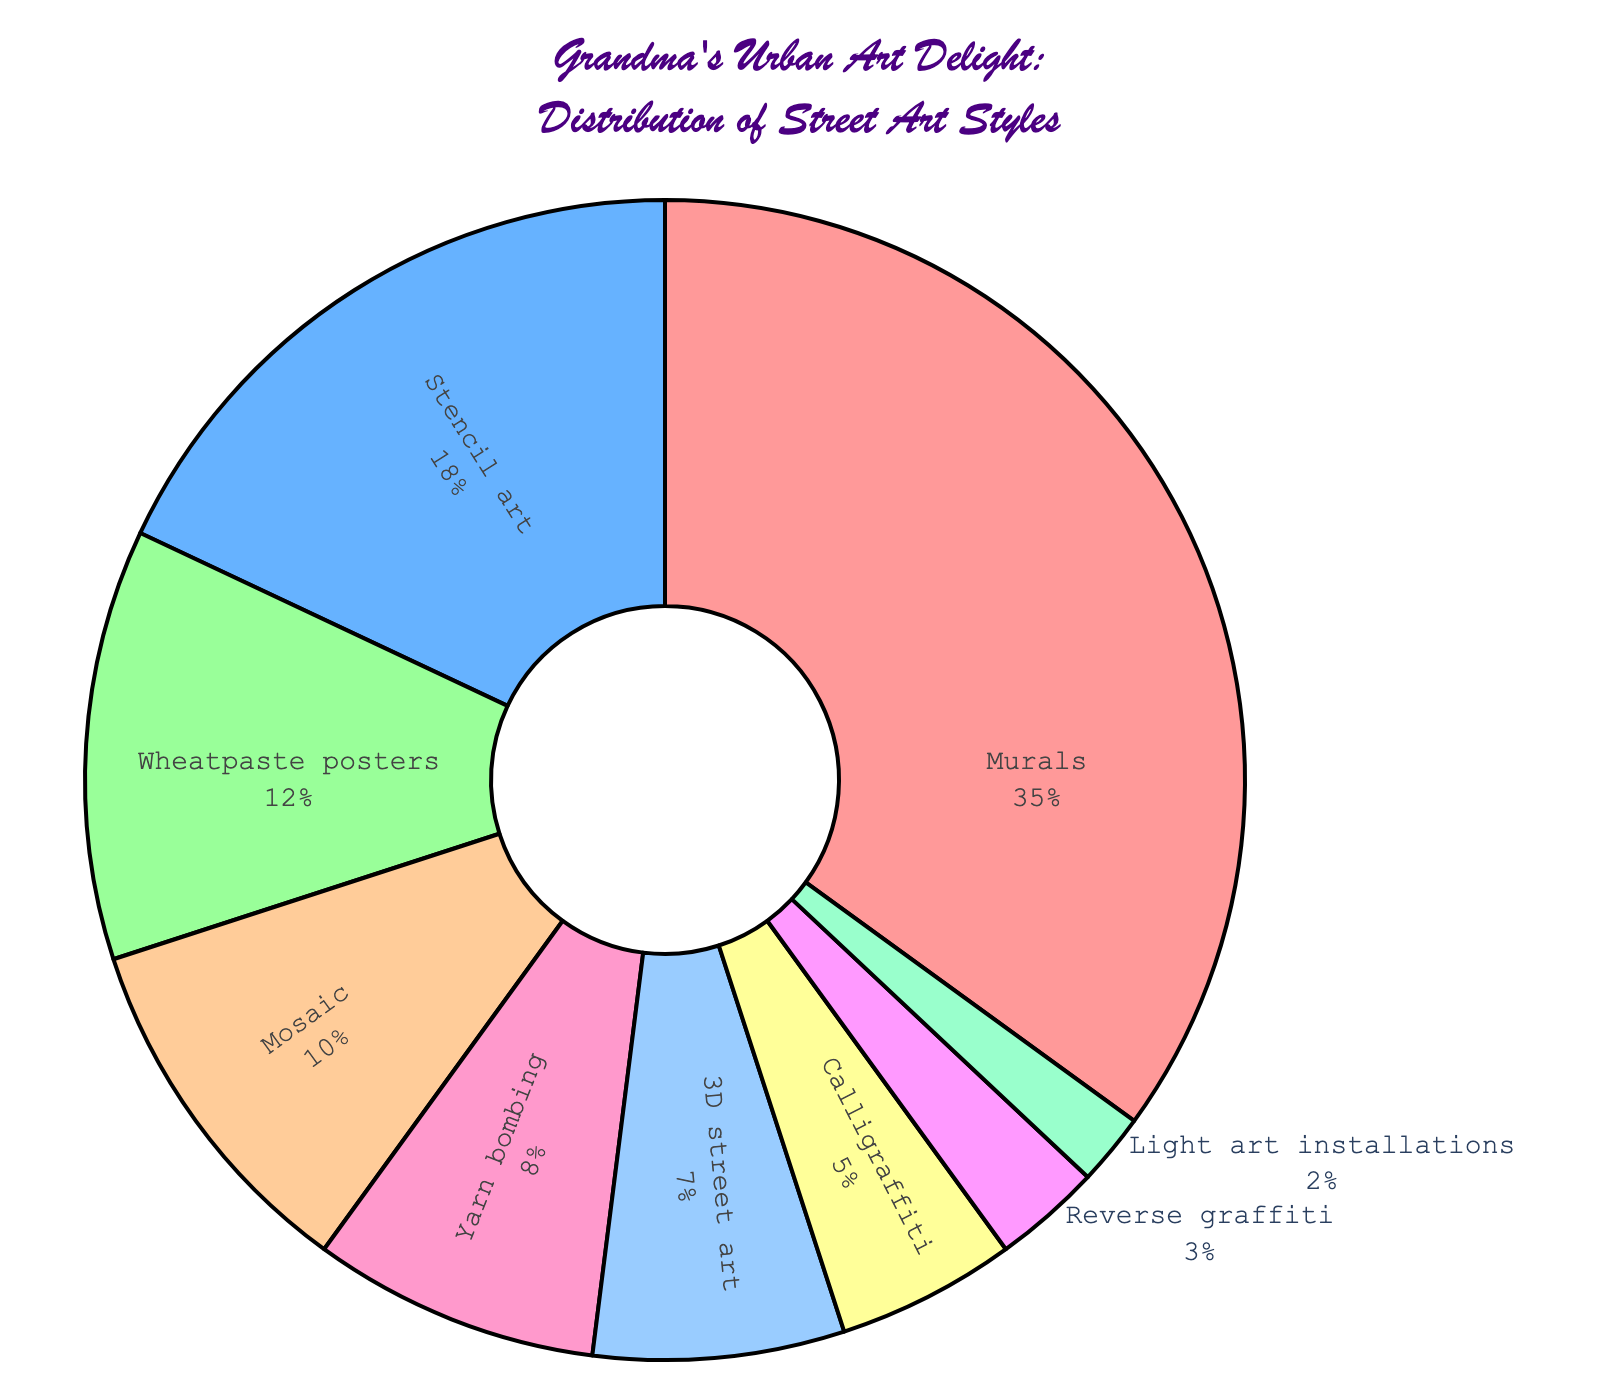What street art style has the greatest proportion in the distribution? The pie chart shows the percentage values, and we can see that the largest segment represents Murals, with 35%.
Answer: Murals What's the combined percentage of Mosaic, Yarn bombing, and 3D street art? Looking at the percentage values for these styles: Mosaic is 10%, Yarn bombing is 8%, and 3D street art is 7%. Adding these together, we get 10% + 8% + 7% = 25%.
Answer: 25% Which has a smaller percentage: Stencil art or Wheatpaste posters? Referring to the pie chart, the percentage for Stencil art is 18%, and for Wheatpaste posters it is 12%. Therefore, Wheatpaste posters have a smaller percentage.
Answer: Wheatpaste posters What's the difference in percentage between Murals and Calligraffiti? The chart shows Murals at 35% and Calligraffiti at 5%. The difference is 35% - 5% = 30%.
Answer: 30% Are there more art styles with a percentage above 10% or below 10%? Styles above 10% include Murals (35%), Stencil art (18%), and Wheatpaste posters (12%)—three styles in total. Styles below 10% include Mosaic (10%), Yarn bombing (8%), 3D street art (7%), Calligraffiti (5%), Reverse graffiti (3%), and Light art installations (2%)—six styles in total. Therefore, there are more art styles below 10%.
Answer: Below 10% Which color is used to represent Light art installations? Observing the pie chart, the segment for Light art installations is in a soft green color.
Answer: Green What's the combined percentage of all art styles with less than 5%? The styles with less than 5% are Calligraffiti (5%), Reverse graffiti (3%), and Light art installations (2%). Adding these together is 5% + 3% + 2% = 10%.
Answer: 10% Which style accounts for over a third of the distribution? According to the pie chart, Murals make up 35%, which is more than one-third of the total distribution.
Answer: Murals 